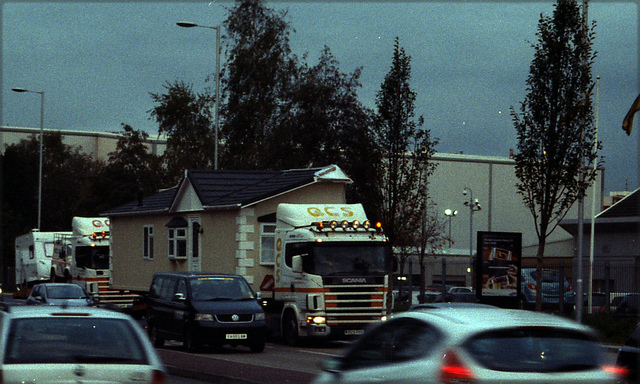Identify the text contained in this image. OCS QCS 